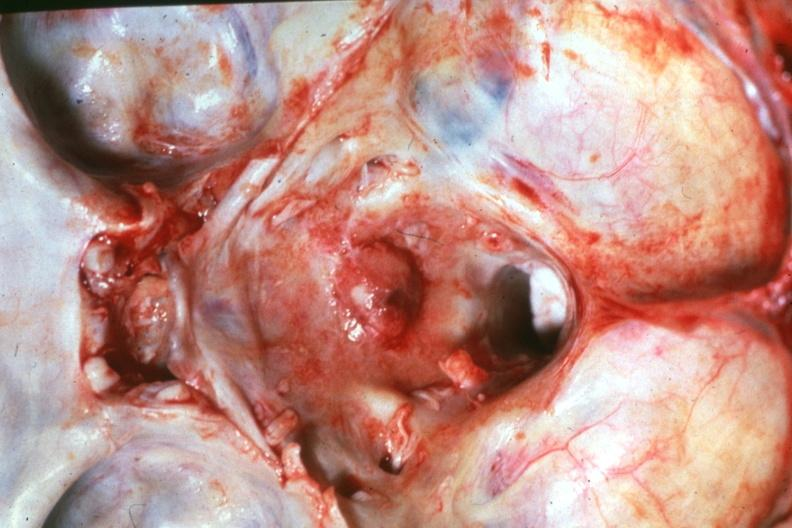what is present?
Answer the question using a single word or phrase. Meningioma in posterior fossa 